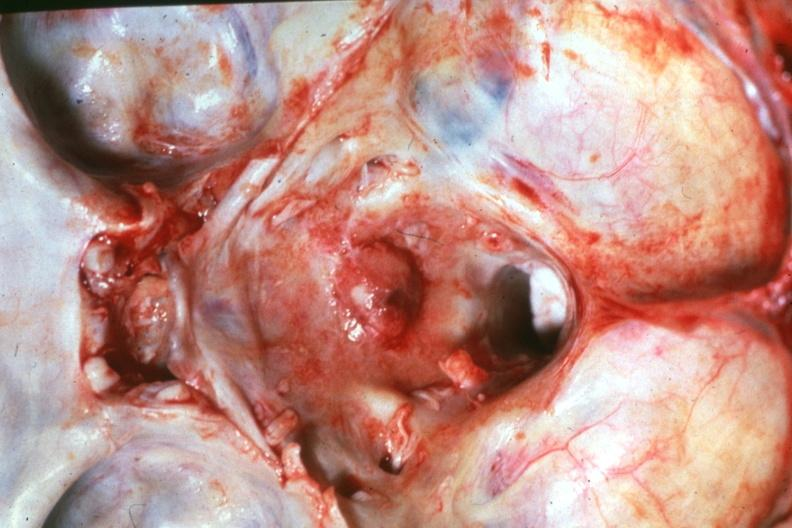what is present?
Answer the question using a single word or phrase. Meningioma in posterior fossa 